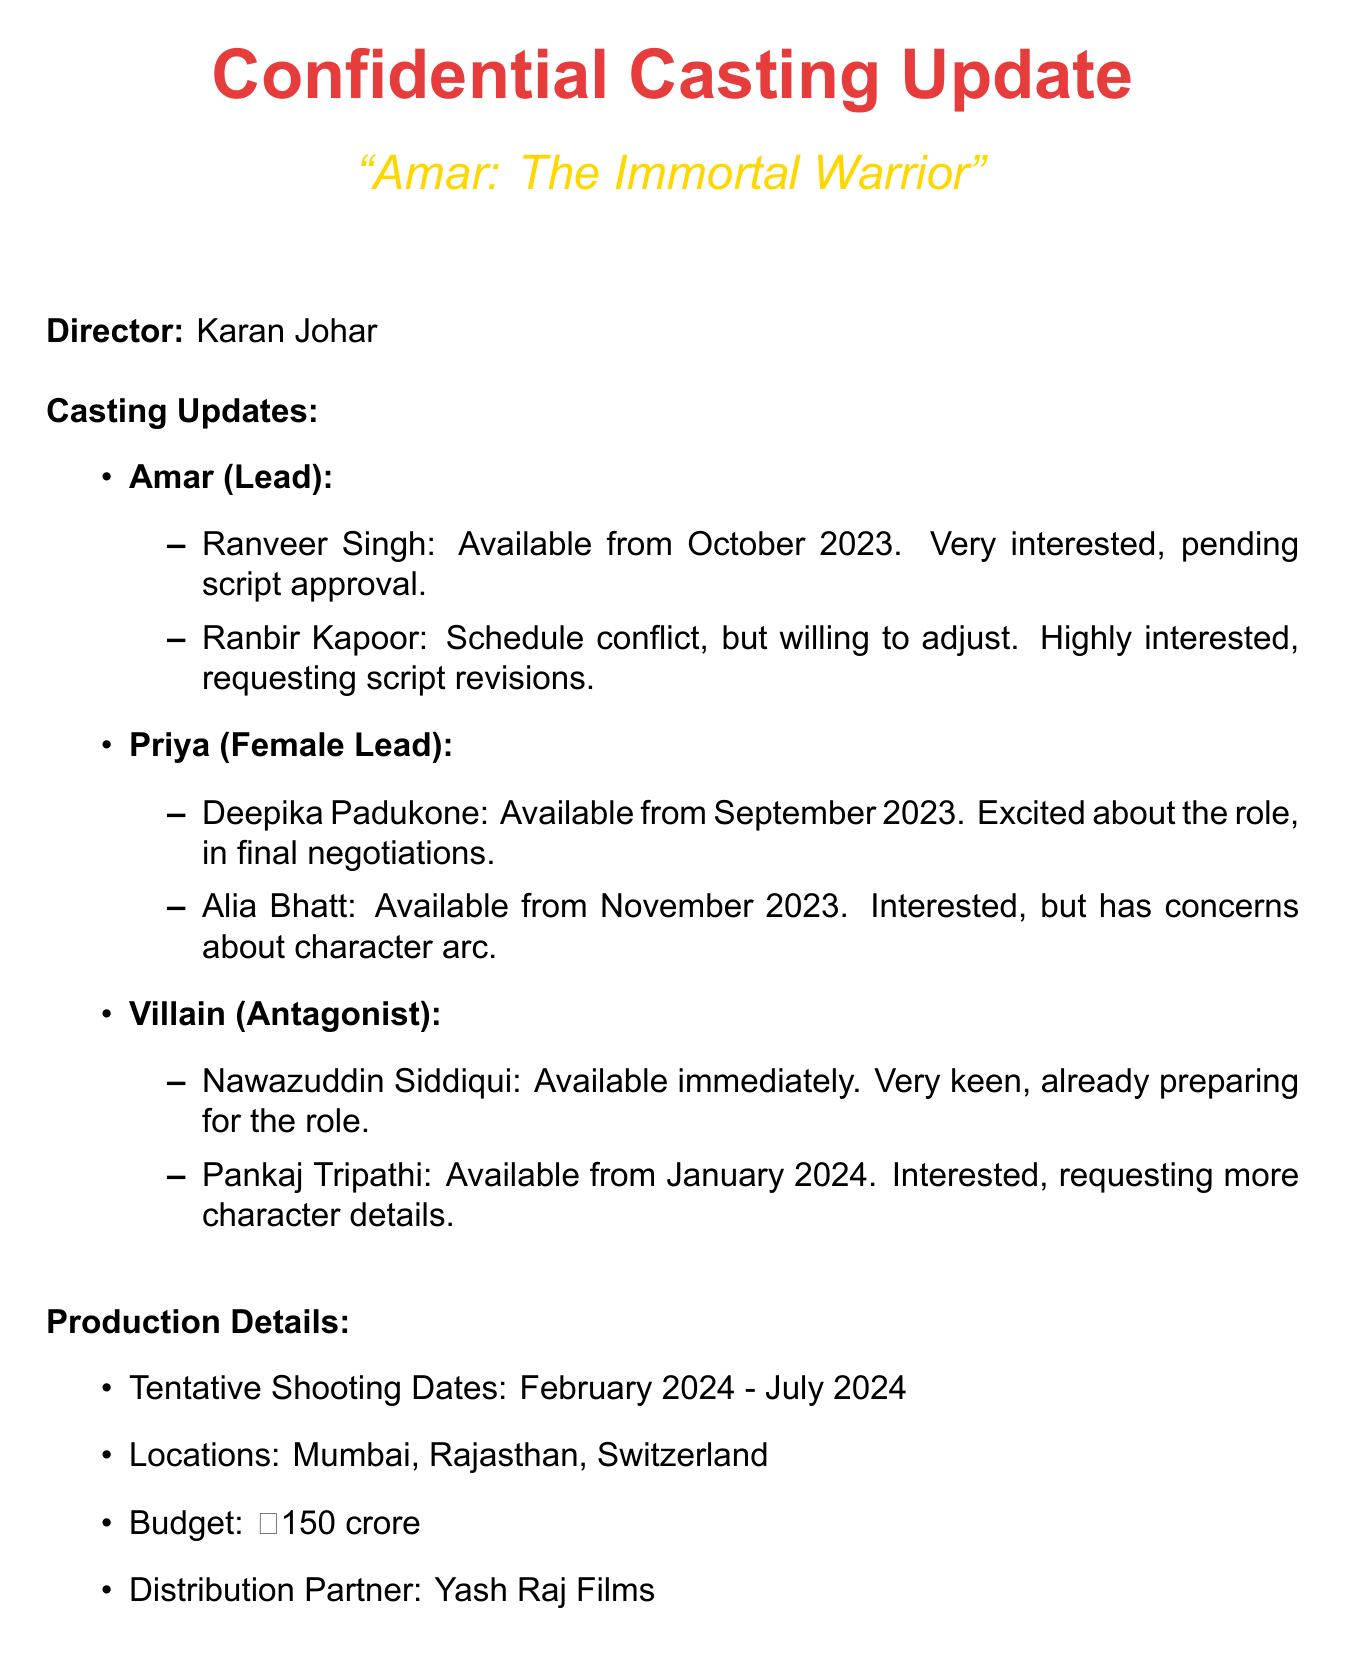What is the title of the film? The title of the film is mentioned in the document as "Amar: The Immortal Warrior".
Answer: Amar: The Immortal Warrior Who is the production company? The document states that the production company is Red Chilli Entertainment.
Answer: Red Chilli Entertainment When will the shooting start? The tentative shooting dates are specified in the document as starting in February 2024.
Answer: February 2024 Which actor is available immediately for the villain role? The document lists Nawazuddin Siddiqui as available immediately for the villain role.
Answer: Nawazuddin Siddiqui What are the locations for shooting? The document mentions three locations for shooting: Mumbai, Rajasthan, and Switzerland.
Answer: Mumbai, Rajasthan, Switzerland Which actor has concerns about their character arc? Alia Bhatt is mentioned in the document as having concerns about the character arc.
Answer: Alia Bhatt What is the budget for the film? The budget for the film is clearly stated as ₹150 crore in the document.
Answer: ₹150 crore What are the final negotiations for the female lead? Deepika Padukone is described in the document as being in final negotiations for the female lead.
Answer: in final negotiations What unique collaboration is being explored for the film? The document indicates that there is an exploration of collaboration with an international stunt choreographer.
Answer: collaboration with international stunt choreographer 